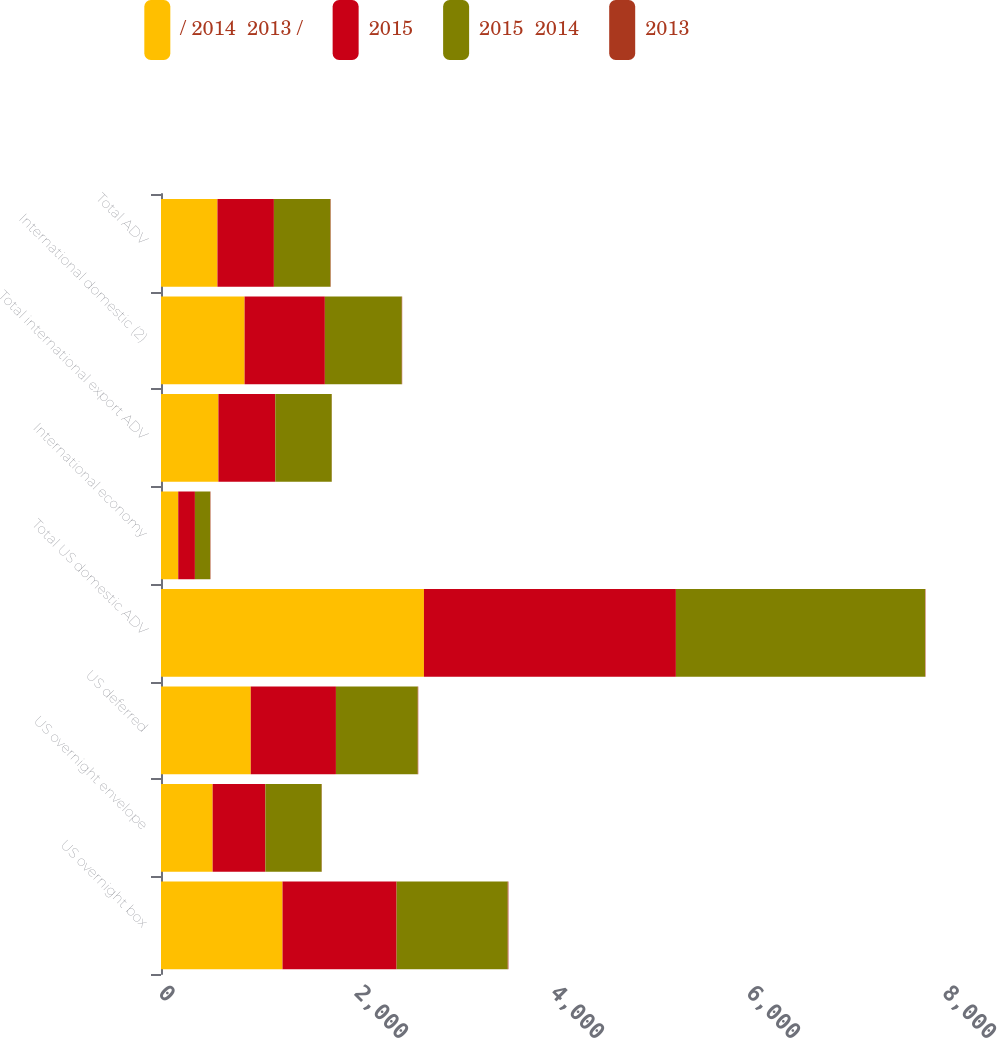Convert chart. <chart><loc_0><loc_0><loc_500><loc_500><stacked_bar_chart><ecel><fcel>US overnight box<fcel>US overnight envelope<fcel>US deferred<fcel>Total US domestic ADV<fcel>International economy<fcel>Total international export ADV<fcel>International domestic (2)<fcel>Total ADV<nl><fcel>/ 2014  2013 /<fcel>1240<fcel>527<fcel>916<fcel>2683<fcel>176<fcel>586<fcel>853<fcel>576<nl><fcel>2015<fcel>1164<fcel>538<fcel>869<fcel>2571<fcel>170<fcel>580<fcel>819<fcel>576<nl><fcel>2015  2014<fcel>1134<fcel>574<fcel>835<fcel>2543<fcel>155<fcel>576<fcel>785<fcel>576<nl><fcel>2013<fcel>7<fcel>2<fcel>5<fcel>4<fcel>4<fcel>1<fcel>4<fcel>4<nl></chart> 